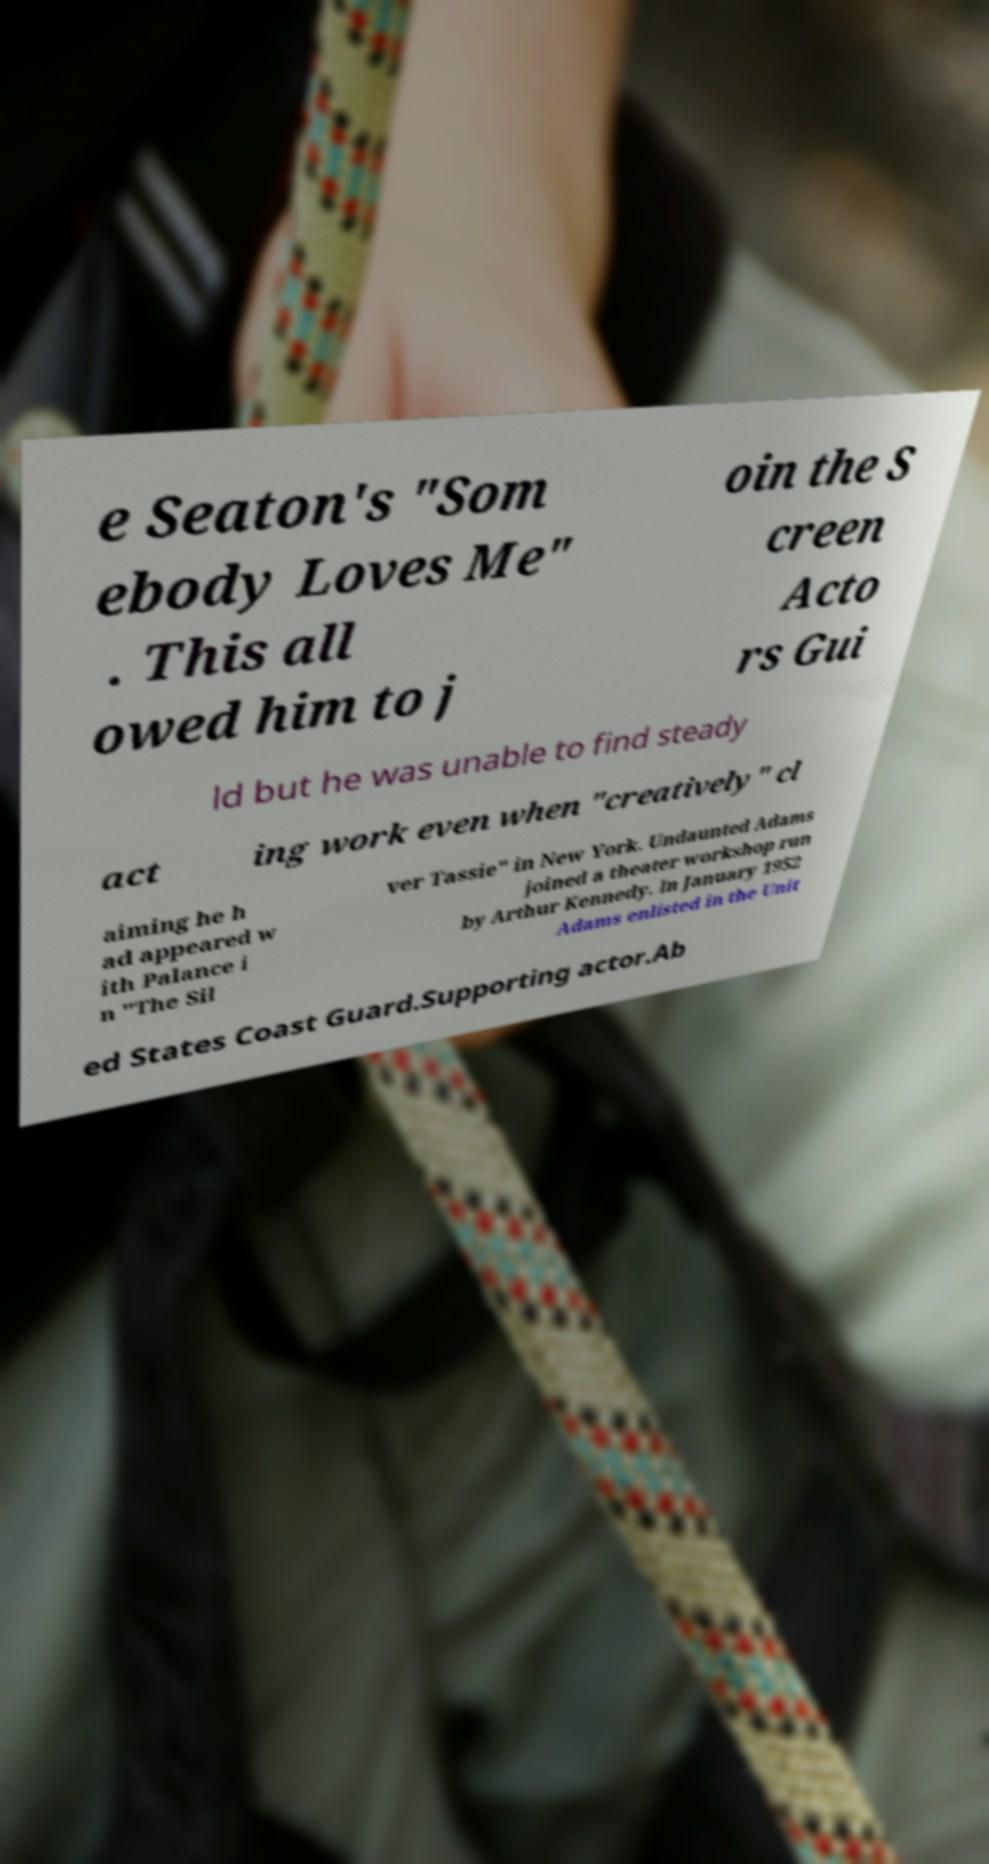Can you accurately transcribe the text from the provided image for me? e Seaton's "Som ebody Loves Me" . This all owed him to j oin the S creen Acto rs Gui ld but he was unable to find steady act ing work even when "creatively" cl aiming he h ad appeared w ith Palance i n "The Sil ver Tassie" in New York. Undaunted Adams joined a theater workshop run by Arthur Kennedy. In January 1952 Adams enlisted in the Unit ed States Coast Guard.Supporting actor.Ab 